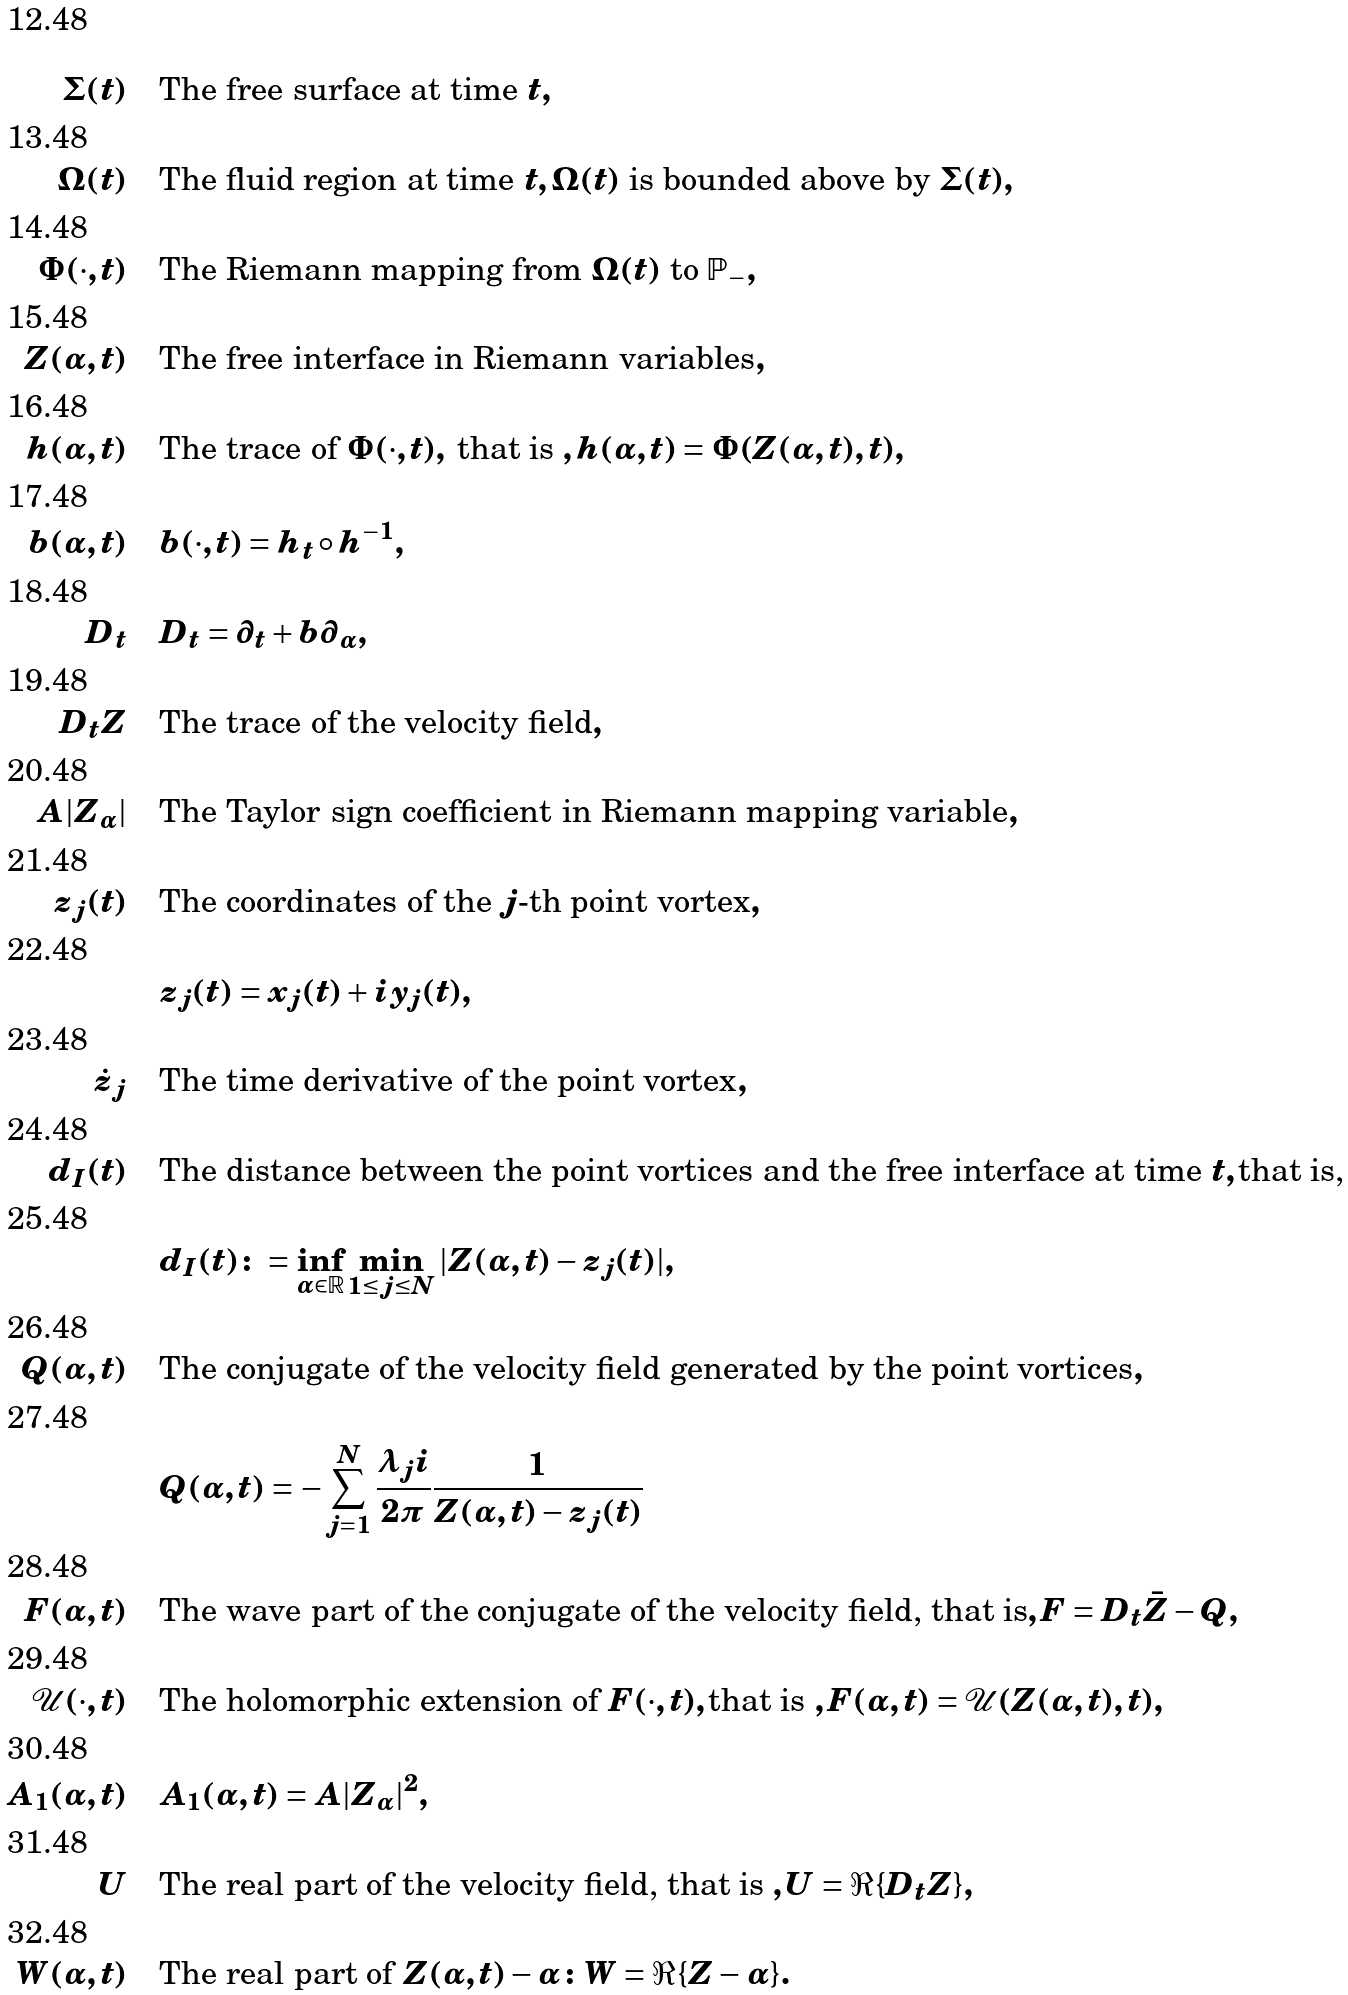<formula> <loc_0><loc_0><loc_500><loc_500>\Sigma ( t ) \quad & \text {The free surface at time } t , \\ \Omega ( t ) \quad & \text {The fluid region at time } t , \Omega ( t ) \text { is bounded above by } \Sigma ( t ) , \\ \Phi ( \cdot , t ) \quad & \text {The Riemann mapping from } \Omega ( t ) \text { to } \mathbb { P } _ { - } , \\ Z ( \alpha , t ) \quad & \text {The free interface in Riemann variables} , \\ h ( \alpha , t ) \quad & \text {The trace of } \Phi ( \cdot , t ) , \text { that is } , h ( \alpha , t ) = \Phi ( Z ( \alpha , t ) , t ) , \\ b ( \alpha , t ) \quad & b ( \cdot , t ) = h _ { t } \circ h ^ { - 1 } , \\ D _ { t } \quad & D _ { t } = \partial _ { t } + b \partial _ { \alpha } , \\ D _ { t } Z \quad & \text {The trace of the velocity field} , \\ A | Z _ { \alpha } | \quad & \text {The Taylor sign coefficient in Riemann mapping variable} , \\ z _ { j } ( t ) \quad & \text {The coordinates of the $j$-th point vortex} , \\ & z _ { j } ( t ) = x _ { j } ( t ) + i y _ { j } ( t ) , \\ \dot { z } _ { j } \quad & \text {The time derivative of the point vortex} , \\ d _ { I } ( t ) \quad & \text {The distance between the point vortices and the free interface at time } t , \text {that is, } \\ & d _ { I } ( t ) \colon = \inf _ { \alpha \in \mathbb { R } } \min _ { 1 \leq j \leq N } | Z ( \alpha , t ) - z _ { j } ( t ) | , \\ Q ( \alpha , t ) \quad & \text {The conjugate of the velocity field generated by the point vortices} , \\ & Q ( \alpha , t ) = - \sum _ { j = 1 } ^ { N } \frac { \lambda _ { j } i } { 2 \pi } \frac { 1 } { Z ( \alpha , t ) - z _ { j } ( t ) } \\ F ( \alpha , t ) \quad & \text {The wave part of the conjugate of the velocity field, that is} , F = D _ { t } \bar { Z } - Q , \\ \mathcal { U } ( \cdot , t ) \quad & \text {The holomorphic extension of } F ( \cdot , t ) , \text {that is } , F ( \alpha , t ) = \mathcal { U } ( Z ( \alpha , t ) , t ) , \\ A _ { 1 } ( \alpha , t ) \quad & A _ { 1 } ( \alpha , t ) = A | Z _ { \alpha } | ^ { 2 } , \\ \ U \quad & \text {The real part of the velocity field, that is } , U = \Re \{ D _ { t } Z \} , \\ W ( \alpha , t ) \quad & \text {The real part of } Z ( \alpha , t ) - \alpha \colon W = \Re \{ Z - \alpha \} .</formula> 